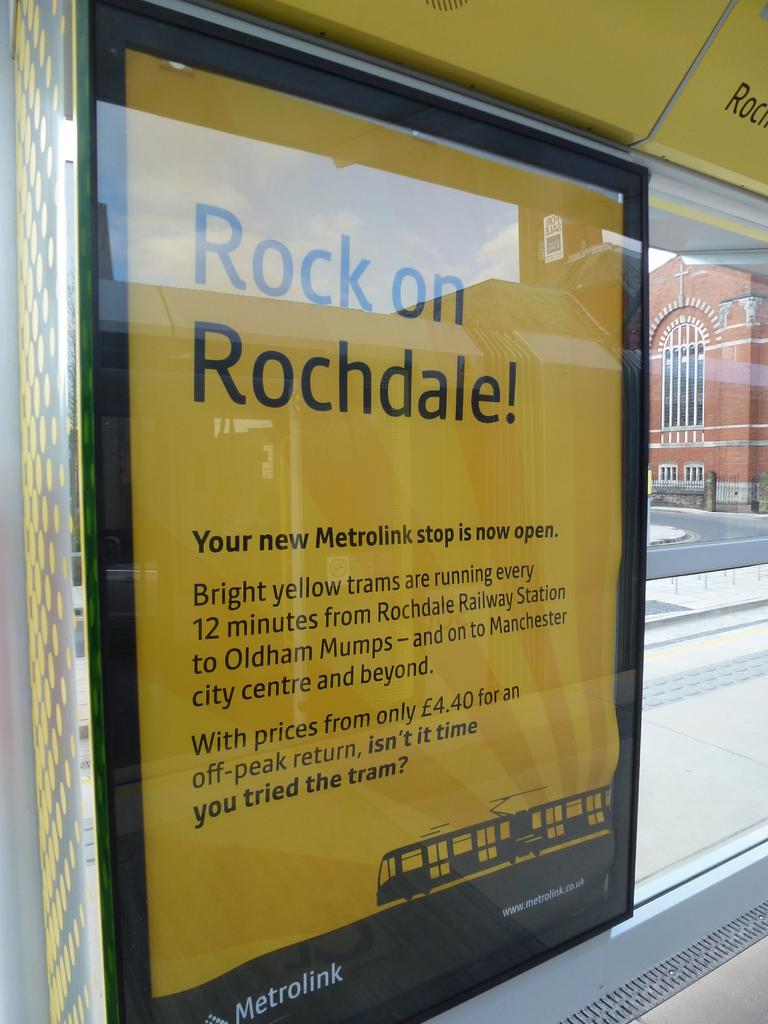<image>
Write a terse but informative summary of the picture. Poster against a window advertising Rock on Rochdale! 